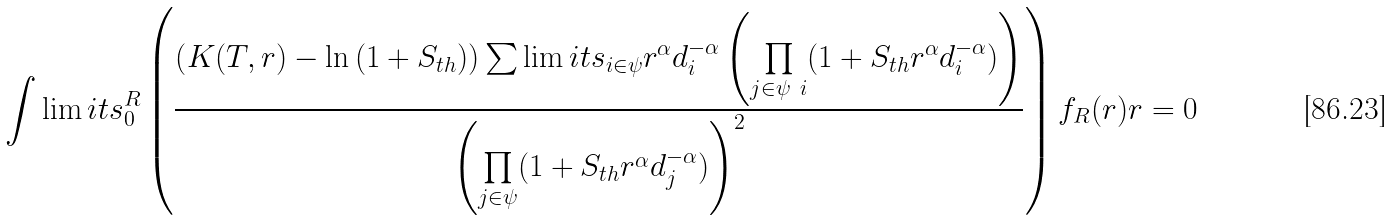<formula> <loc_0><loc_0><loc_500><loc_500>\int \lim i t s _ { 0 } ^ { R } \left ( \frac { \left ( K ( T , r ) - \ln { ( 1 + S _ { t h } ) } \right ) \sum \lim i t s _ { i \in \psi } r ^ { \alpha } d _ { i } ^ { - \alpha } \left ( \underset { j \in \psi \ i } \prod { ( 1 + S _ { t h } r ^ { \alpha } d _ { i } ^ { - \alpha } } ) \right ) } { \left ( \underset { j \in \psi } \prod { ( 1 + S _ { t h } r ^ { \alpha } d _ { j } ^ { - \alpha } ) } \right ) ^ { 2 } } \right ) f _ { R } ( r ) r = 0</formula> 